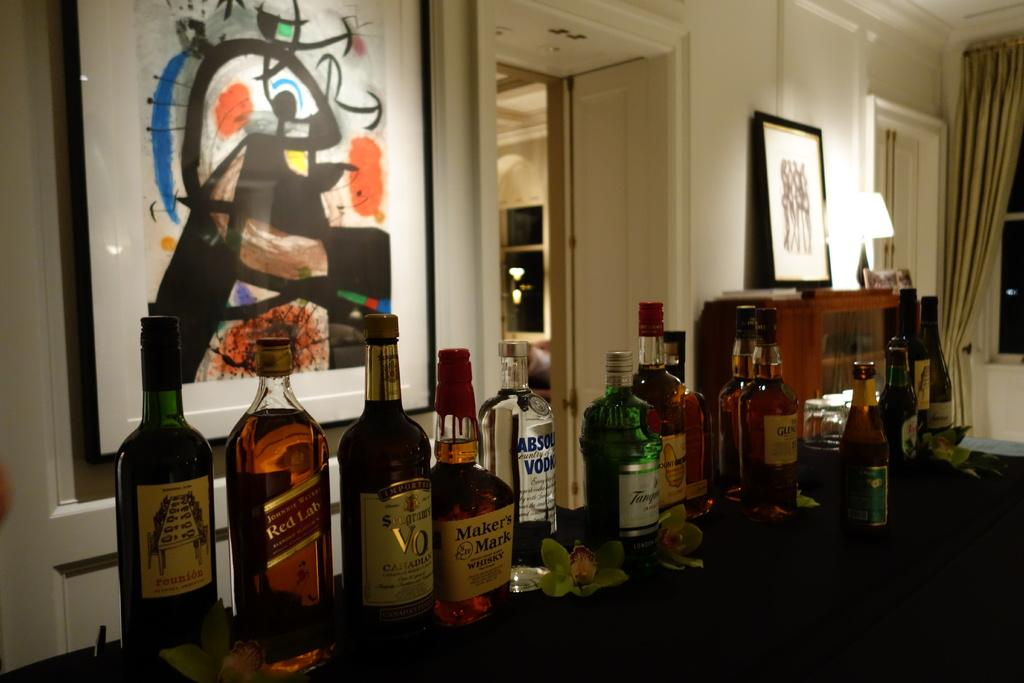<image>
Relay a brief, clear account of the picture shown. Bottles of Makers Mark, Absolut Vodka, Red Label and other liquors are lined up on a table. 